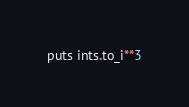<code> <loc_0><loc_0><loc_500><loc_500><_Ruby_>puts ints.to_i**3
</code> 